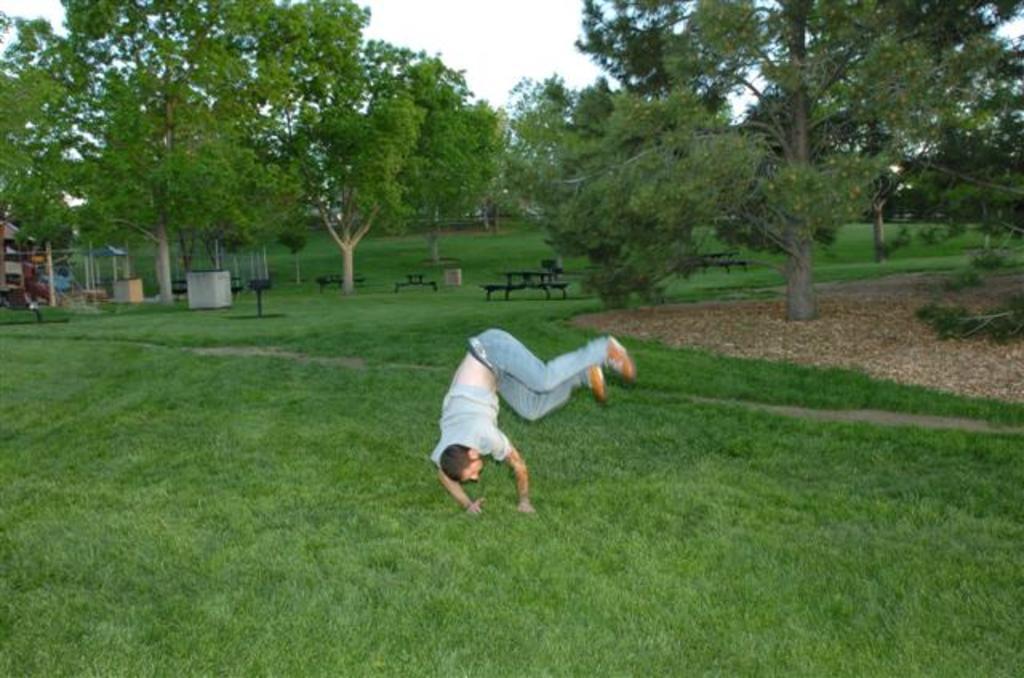How would you summarize this image in a sentence or two? In this picture we can see a man on the grass, in the background we can find few trees, benches and metal rods. 